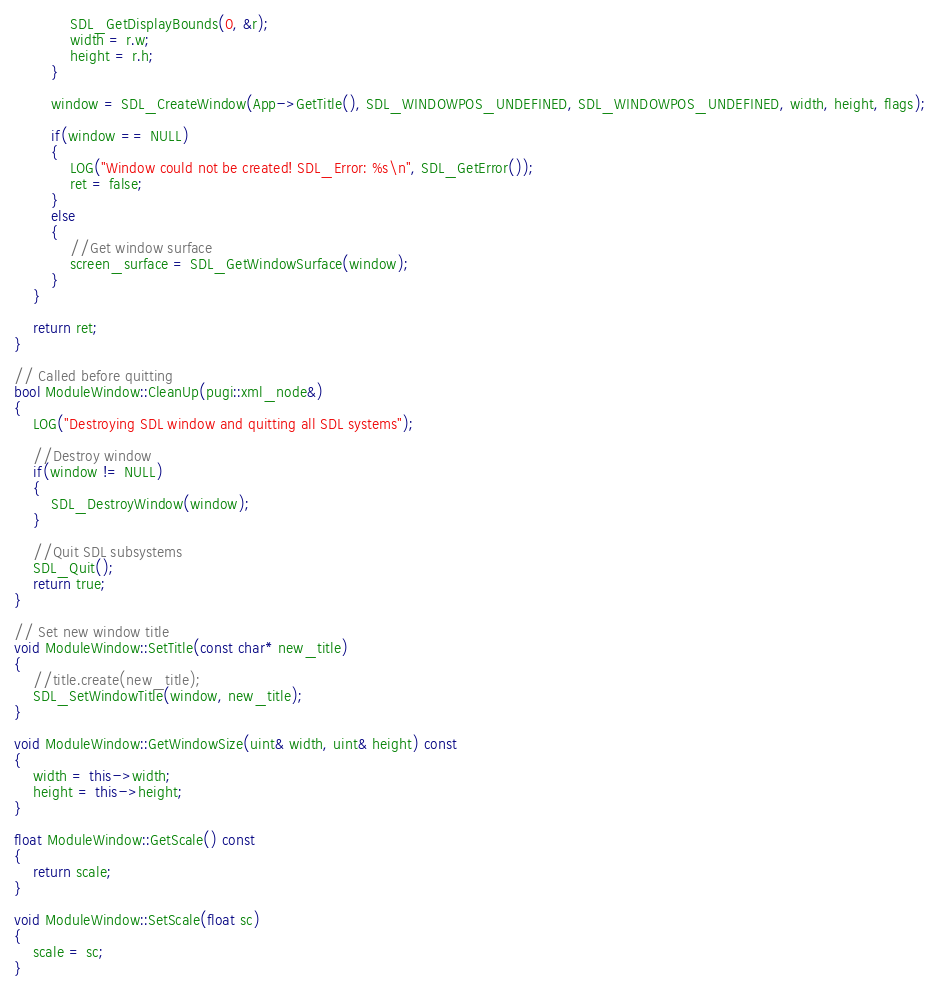<code> <loc_0><loc_0><loc_500><loc_500><_C++_>			SDL_GetDisplayBounds(0, &r);
			width = r.w;
			height = r.h;
		}

		window = SDL_CreateWindow(App->GetTitle(), SDL_WINDOWPOS_UNDEFINED, SDL_WINDOWPOS_UNDEFINED, width, height, flags);

		if(window == NULL)
		{
			LOG("Window could not be created! SDL_Error: %s\n", SDL_GetError());
			ret = false;
		}
		else
		{
			//Get window surface
			screen_surface = SDL_GetWindowSurface(window);
		}
	}

	return ret;
}

// Called before quitting
bool ModuleWindow::CleanUp(pugi::xml_node&)
{
	LOG("Destroying SDL window and quitting all SDL systems");

	//Destroy window
	if(window != NULL)
	{
		SDL_DestroyWindow(window);
	}

	//Quit SDL subsystems
	SDL_Quit();
	return true;
}

// Set new window title
void ModuleWindow::SetTitle(const char* new_title)
{
	//title.create(new_title);
	SDL_SetWindowTitle(window, new_title);
}

void ModuleWindow::GetWindowSize(uint& width, uint& height) const
{
	width = this->width;
	height = this->height;
}

float ModuleWindow::GetScale() const
{
	return scale;
}

void ModuleWindow::SetScale(float sc)
{
	scale = sc;
}</code> 